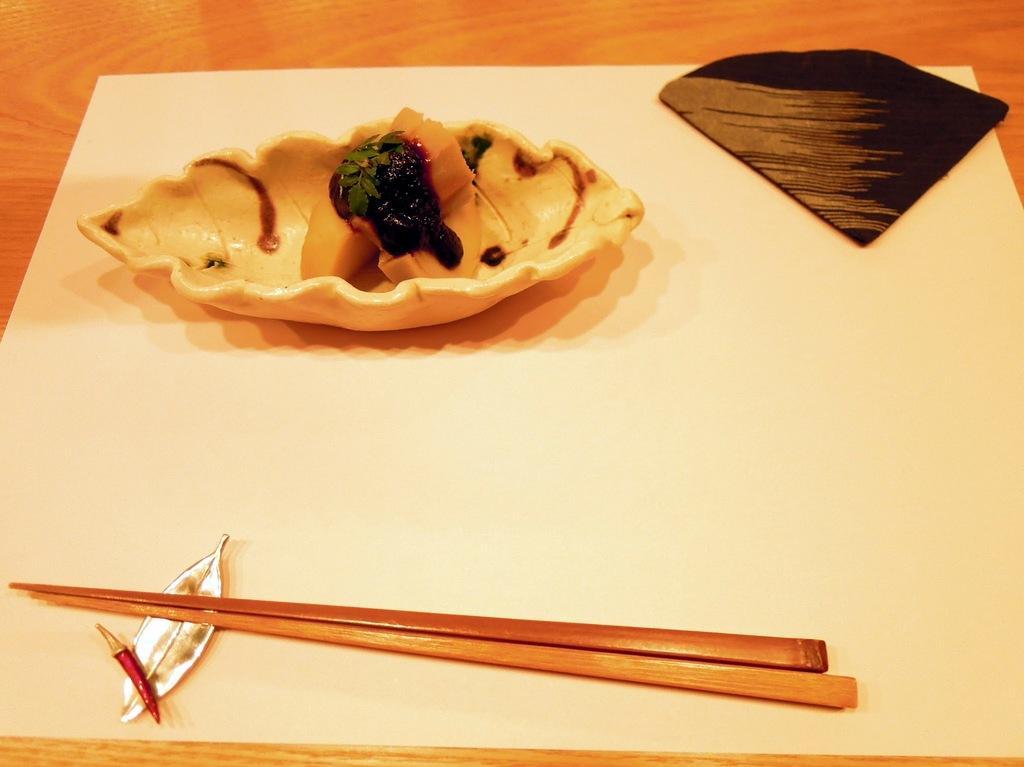How would you summarize this image in a sentence or two? In this picture we can see chopsticks and some food in the plate. 